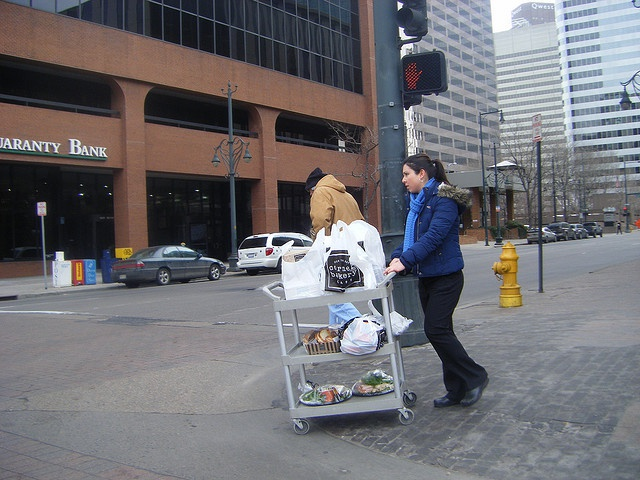Describe the objects in this image and their specific colors. I can see people in black, navy, gray, and darkgray tones, car in black, gray, and darkblue tones, people in black, tan, and gray tones, car in black, lightgray, darkgray, and gray tones, and traffic light in black, darkblue, and maroon tones in this image. 